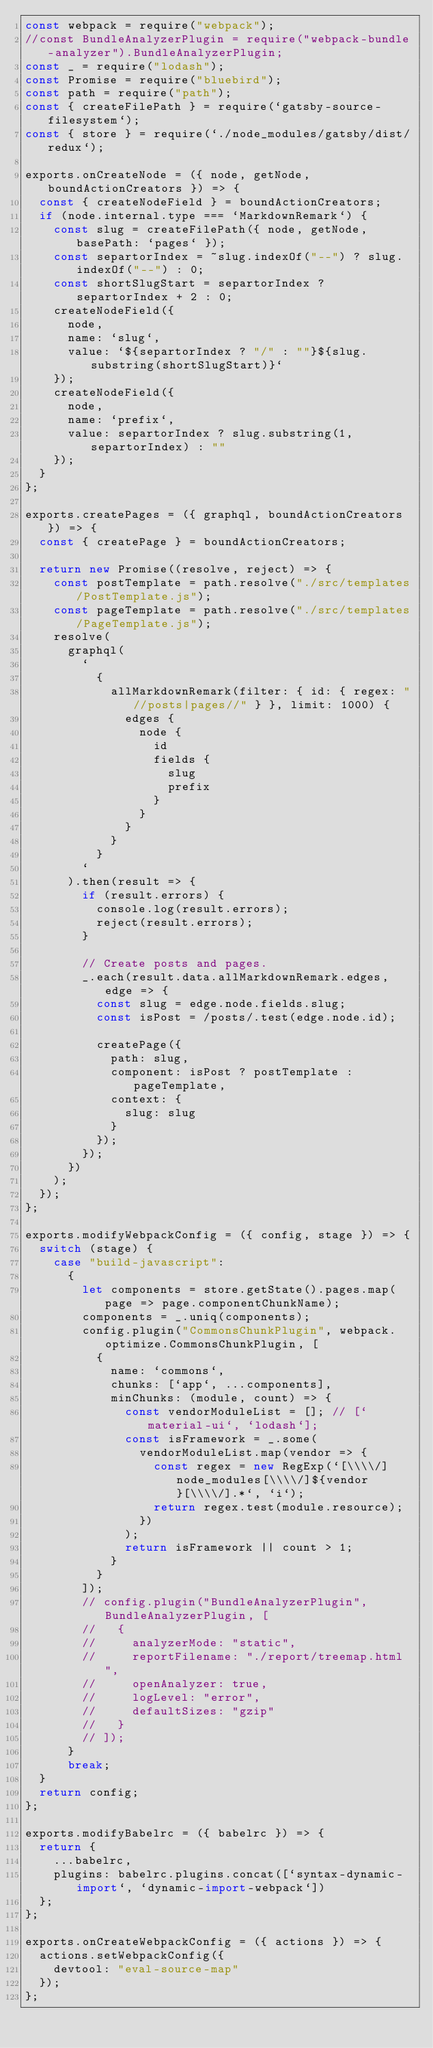Convert code to text. <code><loc_0><loc_0><loc_500><loc_500><_JavaScript_>const webpack = require("webpack");
//const BundleAnalyzerPlugin = require("webpack-bundle-analyzer").BundleAnalyzerPlugin;
const _ = require("lodash");
const Promise = require("bluebird");
const path = require("path");
const { createFilePath } = require(`gatsby-source-filesystem`);
const { store } = require(`./node_modules/gatsby/dist/redux`);

exports.onCreateNode = ({ node, getNode, boundActionCreators }) => {
  const { createNodeField } = boundActionCreators;
  if (node.internal.type === `MarkdownRemark`) {
    const slug = createFilePath({ node, getNode, basePath: `pages` });
    const separtorIndex = ~slug.indexOf("--") ? slug.indexOf("--") : 0;
    const shortSlugStart = separtorIndex ? separtorIndex + 2 : 0;
    createNodeField({
      node,
      name: `slug`,
      value: `${separtorIndex ? "/" : ""}${slug.substring(shortSlugStart)}`
    });
    createNodeField({
      node,
      name: `prefix`,
      value: separtorIndex ? slug.substring(1, separtorIndex) : ""
    });
  }
};

exports.createPages = ({ graphql, boundActionCreators }) => {
  const { createPage } = boundActionCreators;

  return new Promise((resolve, reject) => {
    const postTemplate = path.resolve("./src/templates/PostTemplate.js");
    const pageTemplate = path.resolve("./src/templates/PageTemplate.js");
    resolve(
      graphql(
        `
          {
            allMarkdownRemark(filter: { id: { regex: "//posts|pages//" } }, limit: 1000) {
              edges {
                node {
                  id
                  fields {
                    slug
                    prefix
                  }
                }
              }
            }
          }
        `
      ).then(result => {
        if (result.errors) {
          console.log(result.errors);
          reject(result.errors);
        }

        // Create posts and pages.
        _.each(result.data.allMarkdownRemark.edges, edge => {
          const slug = edge.node.fields.slug;
          const isPost = /posts/.test(edge.node.id);

          createPage({
            path: slug,
            component: isPost ? postTemplate : pageTemplate,
            context: {
              slug: slug
            }
          });
        });
      })
    );
  });
};

exports.modifyWebpackConfig = ({ config, stage }) => {
  switch (stage) {
    case "build-javascript":
      {
        let components = store.getState().pages.map(page => page.componentChunkName);
        components = _.uniq(components);
        config.plugin("CommonsChunkPlugin", webpack.optimize.CommonsChunkPlugin, [
          {
            name: `commons`,
            chunks: [`app`, ...components],
            minChunks: (module, count) => {
              const vendorModuleList = []; // [`material-ui`, `lodash`];
              const isFramework = _.some(
                vendorModuleList.map(vendor => {
                  const regex = new RegExp(`[\\\\/]node_modules[\\\\/]${vendor}[\\\\/].*`, `i`);
                  return regex.test(module.resource);
                })
              );
              return isFramework || count > 1;
            }
          }
        ]);
        // config.plugin("BundleAnalyzerPlugin", BundleAnalyzerPlugin, [
        //   {
        //     analyzerMode: "static",
        //     reportFilename: "./report/treemap.html",
        //     openAnalyzer: true,
        //     logLevel: "error",
        //     defaultSizes: "gzip"
        //   }
        // ]);
      }
      break;
  }
  return config;
};

exports.modifyBabelrc = ({ babelrc }) => {
  return {
    ...babelrc,
    plugins: babelrc.plugins.concat([`syntax-dynamic-import`, `dynamic-import-webpack`])
  };
};

exports.onCreateWebpackConfig = ({ actions }) => {
  actions.setWebpackConfig({
    devtool: "eval-source-map"
  });
};
</code> 